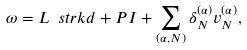<formula> <loc_0><loc_0><loc_500><loc_500>\omega = L \ s t r k { d } + P I + \sum _ { ( \alpha , N ) } \delta _ { N } ^ { ( \alpha ) } v _ { N } ^ { ( \alpha ) } ,</formula> 